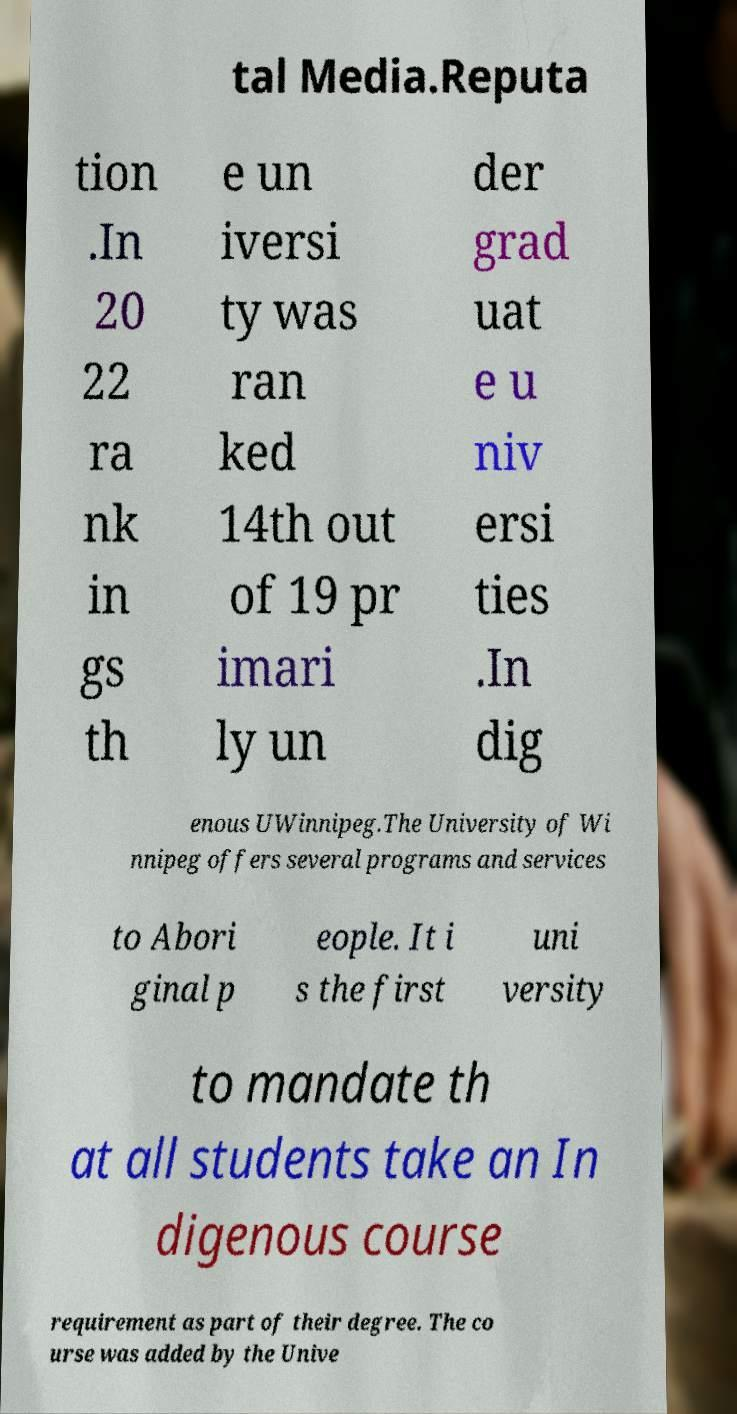Could you assist in decoding the text presented in this image and type it out clearly? tal Media.Reputa tion .In 20 22 ra nk in gs th e un iversi ty was ran ked 14th out of 19 pr imari ly un der grad uat e u niv ersi ties .In dig enous UWinnipeg.The University of Wi nnipeg offers several programs and services to Abori ginal p eople. It i s the first uni versity to mandate th at all students take an In digenous course requirement as part of their degree. The co urse was added by the Unive 